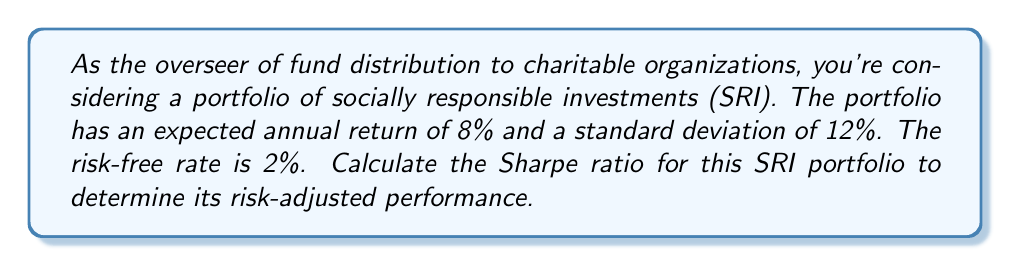Can you answer this question? To calculate the Sharpe ratio for the SRI portfolio, we need to follow these steps:

1. Identify the given information:
   - Expected annual return of the portfolio (R_p) = 8%
   - Standard deviation of the portfolio (σ_p) = 12%
   - Risk-free rate (R_f) = 2%

2. The Sharpe ratio is calculated using the following formula:

   $$\text{Sharpe Ratio} = \frac{R_p - R_f}{\sigma_p}$$

   Where:
   - R_p is the expected portfolio return
   - R_f is the risk-free rate
   - σ_p is the standard deviation of the portfolio (measure of risk)

3. Plug in the values:

   $$\text{Sharpe Ratio} = \frac{0.08 - 0.02}{0.12}$$

4. Perform the calculation:

   $$\text{Sharpe Ratio} = \frac{0.06}{0.12} = 0.5$$

The Sharpe ratio of 0.5 indicates the risk-adjusted return of the SRI portfolio. This means that for each unit of risk (as measured by standard deviation), the portfolio is expected to deliver 0.5 units of excess return over the risk-free rate.
Answer: The Sharpe ratio for the SRI portfolio is 0.5. 